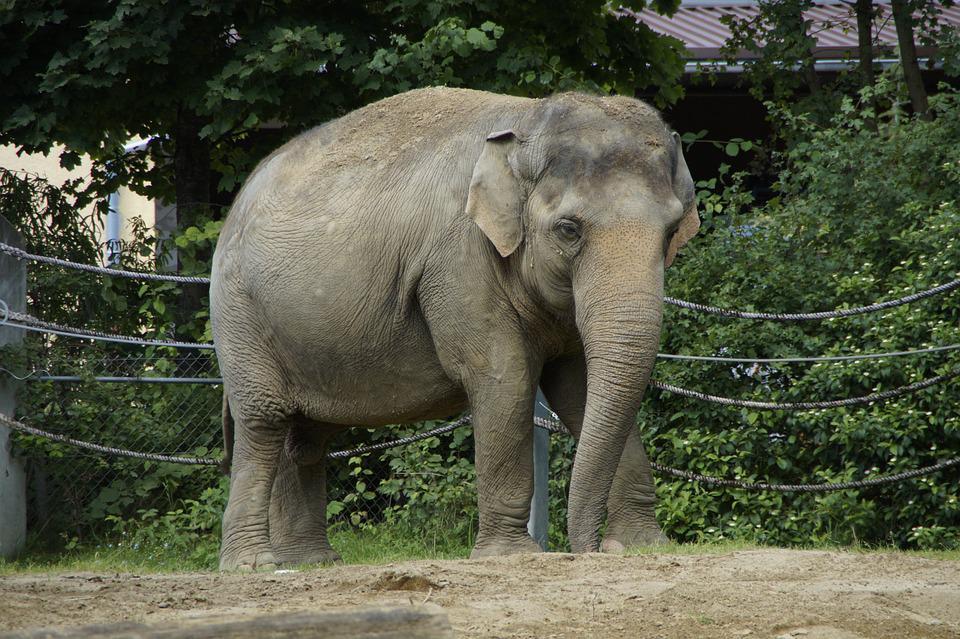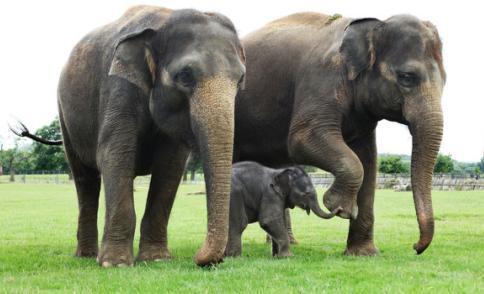The first image is the image on the left, the second image is the image on the right. Analyze the images presented: Is the assertion "At least one image is exactly one baby elephant standing between two adults." valid? Answer yes or no. Yes. 